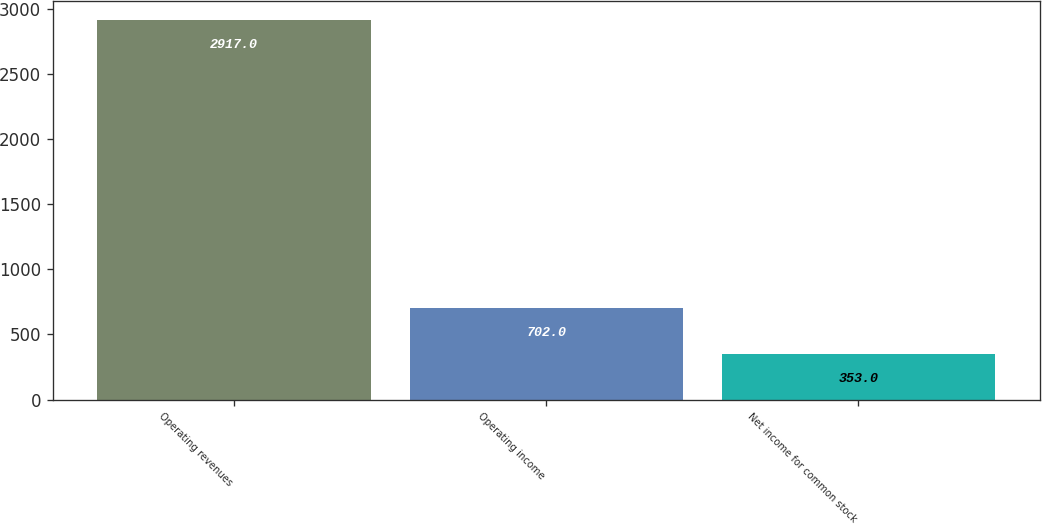Convert chart. <chart><loc_0><loc_0><loc_500><loc_500><bar_chart><fcel>Operating revenues<fcel>Operating income<fcel>Net income for common stock<nl><fcel>2917<fcel>702<fcel>353<nl></chart> 